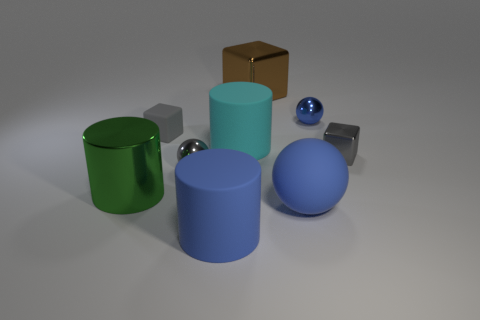Add 1 tiny purple matte cylinders. How many objects exist? 10 Subtract all cylinders. How many objects are left? 6 Subtract all green matte cylinders. Subtract all blue metal balls. How many objects are left? 8 Add 2 brown objects. How many brown objects are left? 3 Add 6 yellow metal blocks. How many yellow metal blocks exist? 6 Subtract 0 green cubes. How many objects are left? 9 